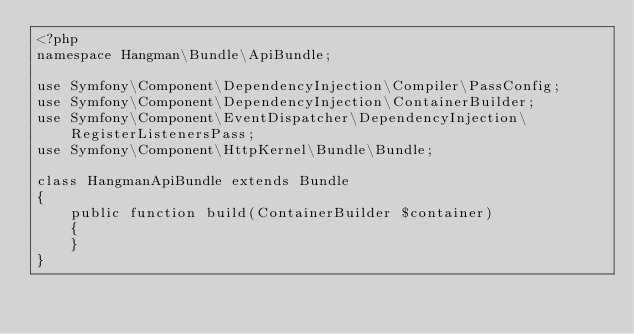<code> <loc_0><loc_0><loc_500><loc_500><_PHP_><?php
namespace Hangman\Bundle\ApiBundle;

use Symfony\Component\DependencyInjection\Compiler\PassConfig;
use Symfony\Component\DependencyInjection\ContainerBuilder;
use Symfony\Component\EventDispatcher\DependencyInjection\RegisterListenersPass;
use Symfony\Component\HttpKernel\Bundle\Bundle;

class HangmanApiBundle extends Bundle
{
    public function build(ContainerBuilder $container)
    {
    }
}
</code> 